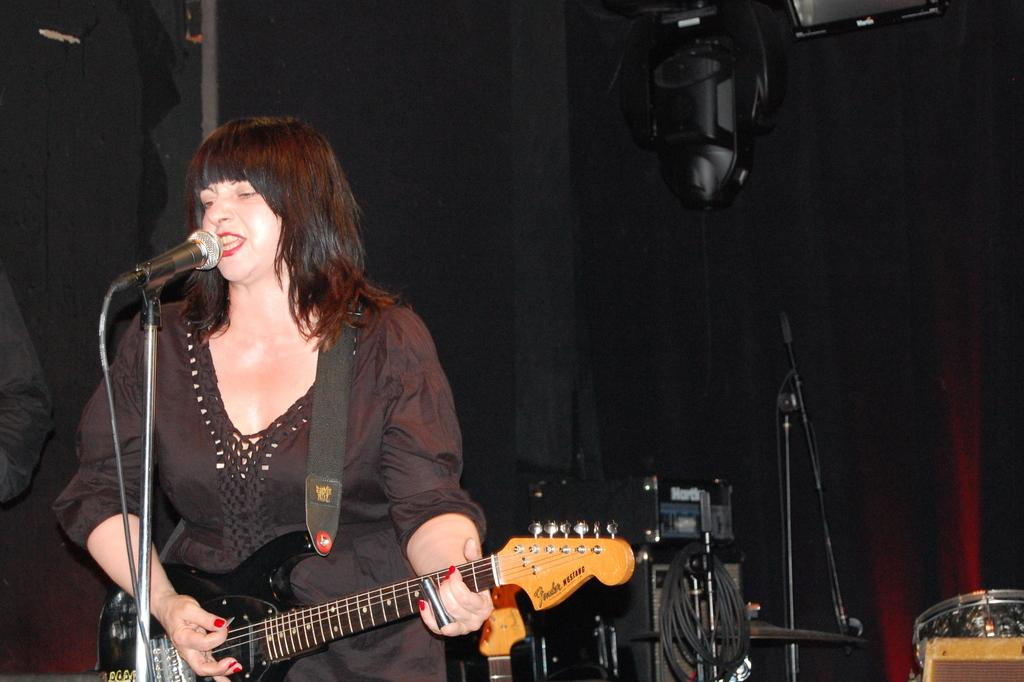Who is the main subject in the image? There is a woman in the image. What is the woman holding in the image? The woman is holding a guitar. Where is the woman positioned in the image? The woman is standing in front of a mic. What can be seen in the background of the image? There are equipment visible in the background of the image. What type of plastic is used to make the hospital bed in the image? There is no hospital bed present in the image. 